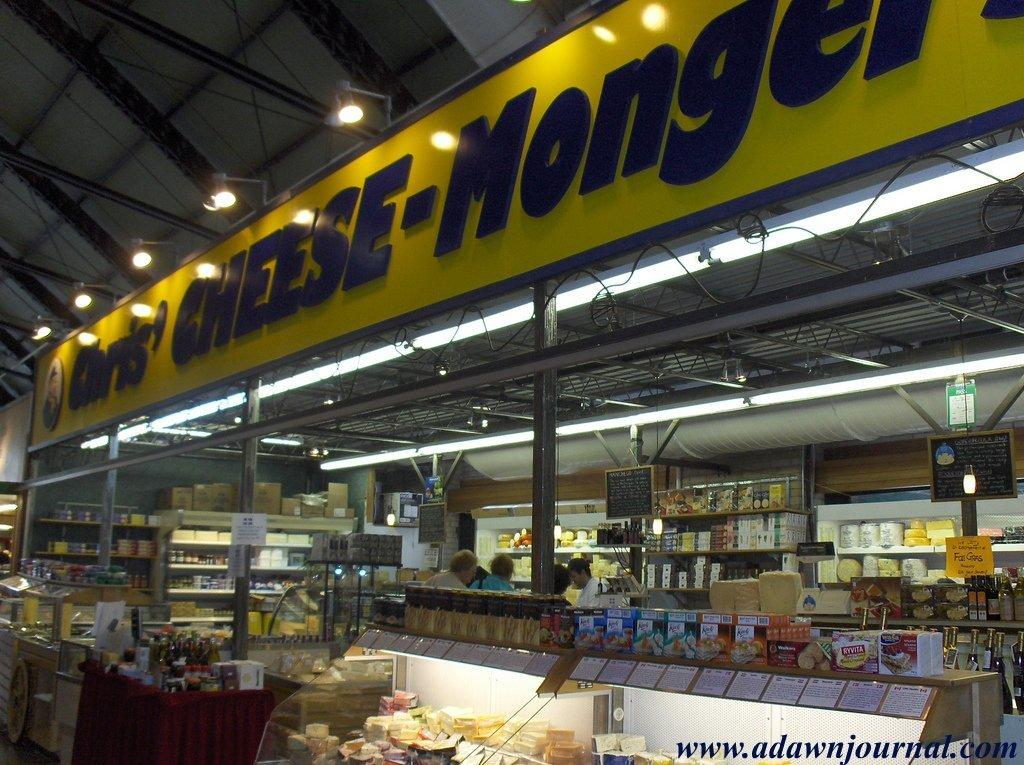Provide a one-sentence caption for the provided image. A store called Chris' Cheese-Mongers has people shopping inside. 